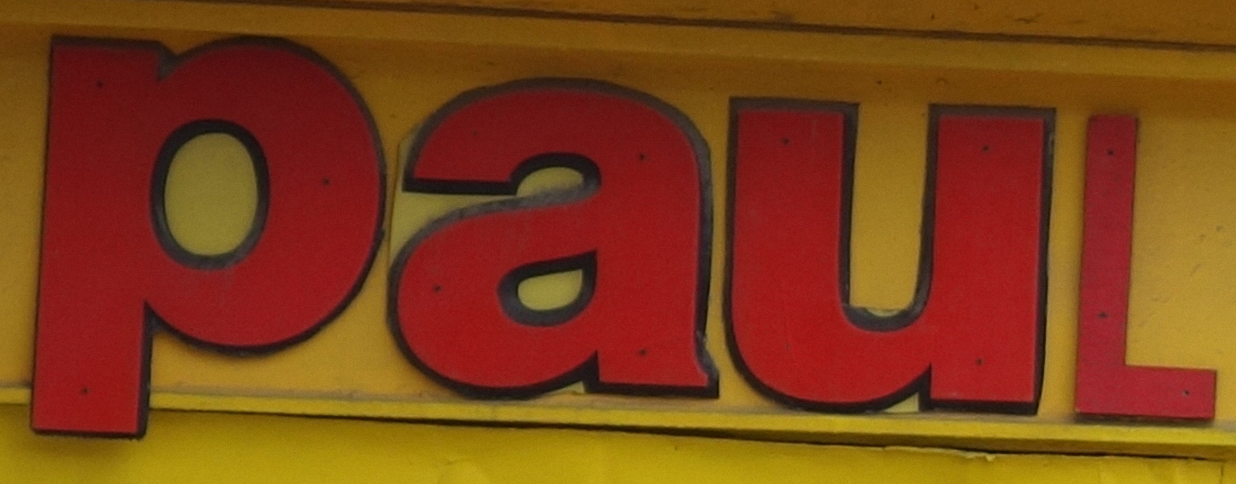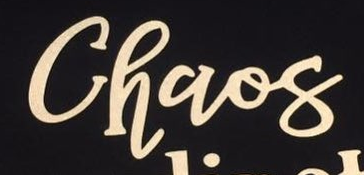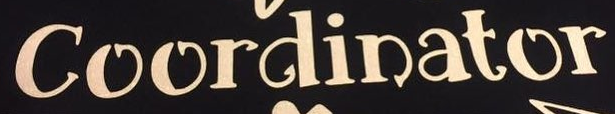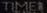What text appears in these images from left to right, separated by a semicolon? PauL; Chaos; Coordinator; TIMEI 